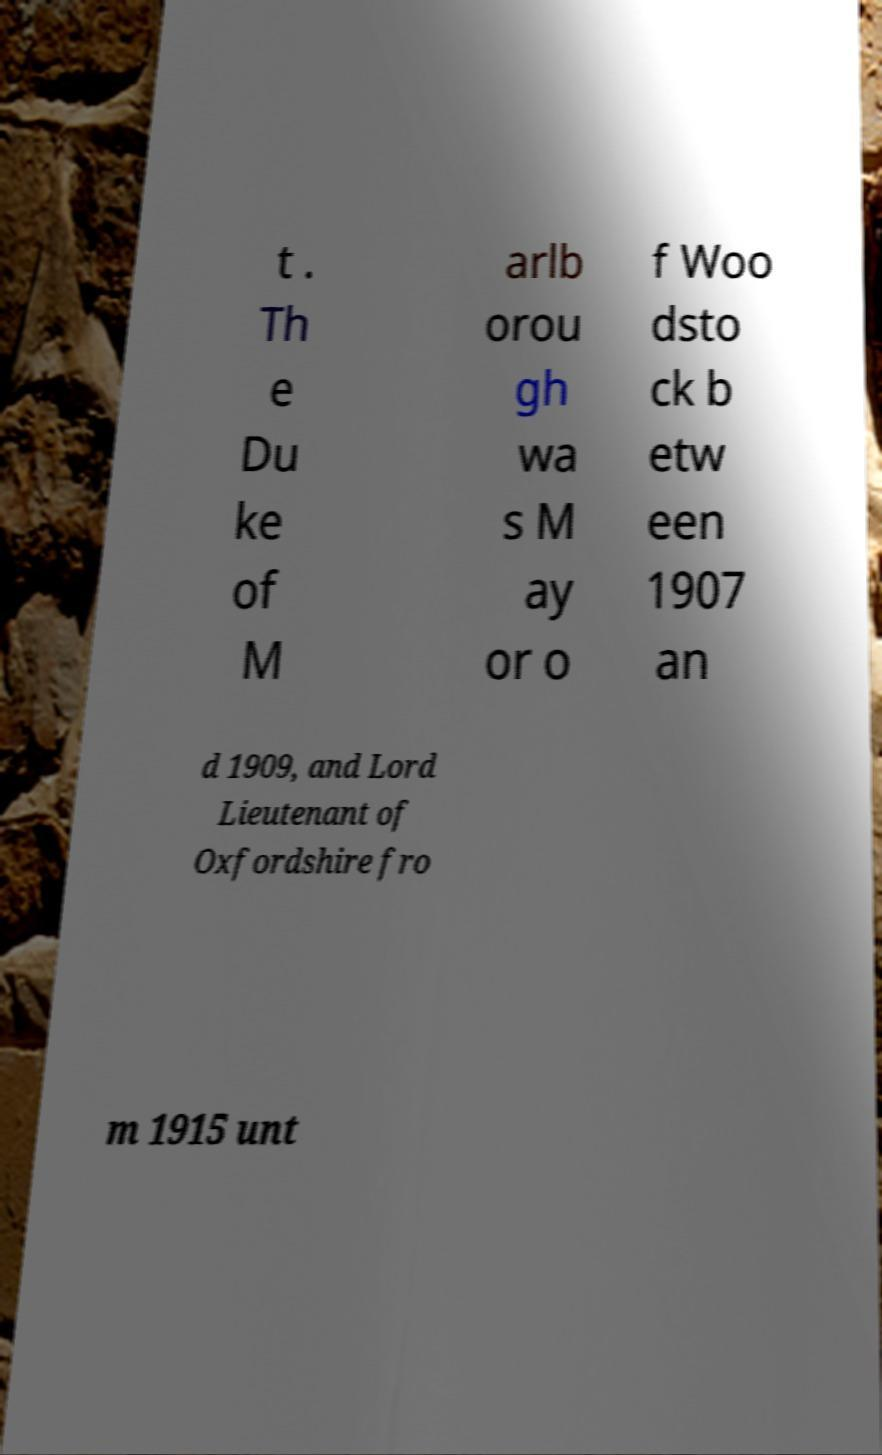I need the written content from this picture converted into text. Can you do that? t . Th e Du ke of M arlb orou gh wa s M ay or o f Woo dsto ck b etw een 1907 an d 1909, and Lord Lieutenant of Oxfordshire fro m 1915 unt 